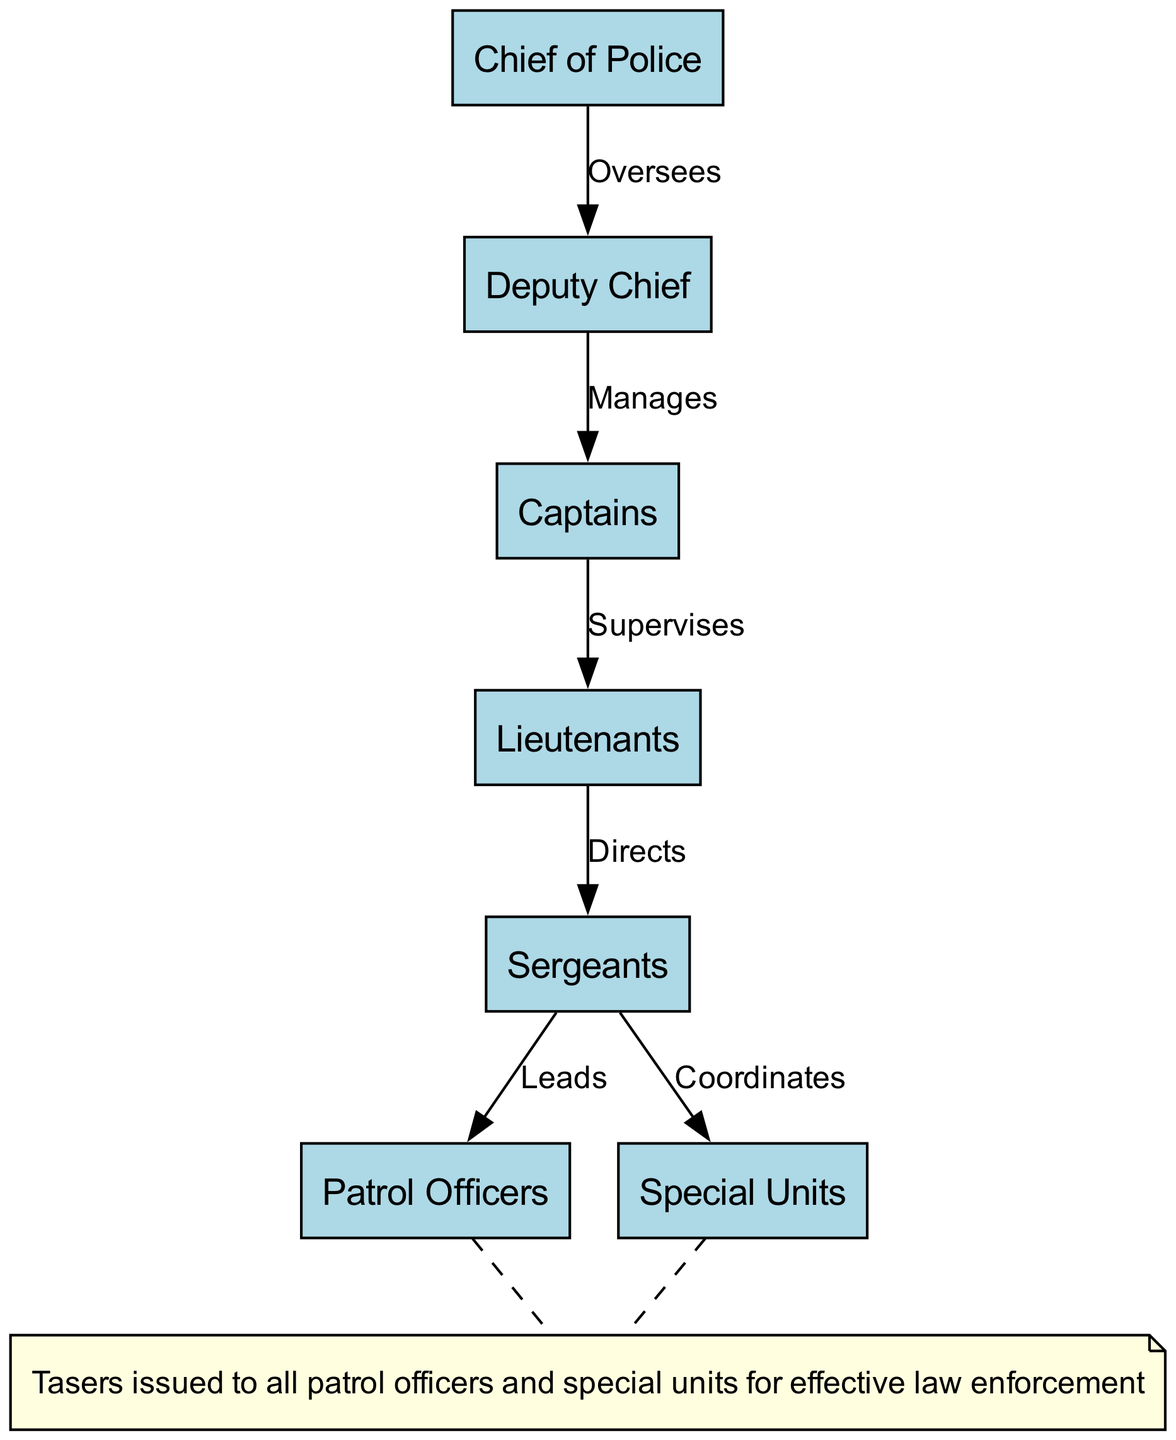What is the highest position in the organizational structure? The diagram indicates that the "Chief of Police" is at the top of the organizational structure, as it has no nodes above it.
Answer: Chief of Police How many nodes are there in the diagram? By counting the distinct positions listed as nodes, we identify six nodes: Chief of Police, Deputy Chief, Captains, Lieutenants, Sergeants, Patrol Officers, and Special Units. Thus, the total is six.
Answer: 6 What is the role of the Deputy Chief in the hierarchy? The Deputy Chief's role is described in the diagram as "Manages," which indicates its position delegating tasks to Captains.
Answer: Manages Which position directly supervises Patrol Officers? The diagram shows that "Sergeants" lead Patrol Officers, indicating a direct supervisory role.
Answer: Sergeants How many edges are there in the diagram? The edges represent the relations between the nodes. Counting them indicates there are five edges connecting various positions in the hierarchy.
Answer: 5 What label indicates the relationship between Captains and Lieutenants? The relationship between Captains and Lieutenants is indicated by the label "Supervises" written on the edge connecting these two nodes.
Answer: Supervises Which two positions coordinate with special units? According to the diagram, "Sergeants" coordinate with "Special Units," meaning that Sergeants take charge of planning and organizing these specialized teams.
Answer: Sergeants What is issued to all patrol officers for effective law enforcement? The note at the bottom of the diagram states that "Tasers" are issued to all patrol officers for this purpose.
Answer: Tasers What is the position below Lieutenants in the organization? The diagram shows that "Sergeants" are placed directly below Lieutenants, outlining it as the next level in the hierarchy.
Answer: Sergeants 